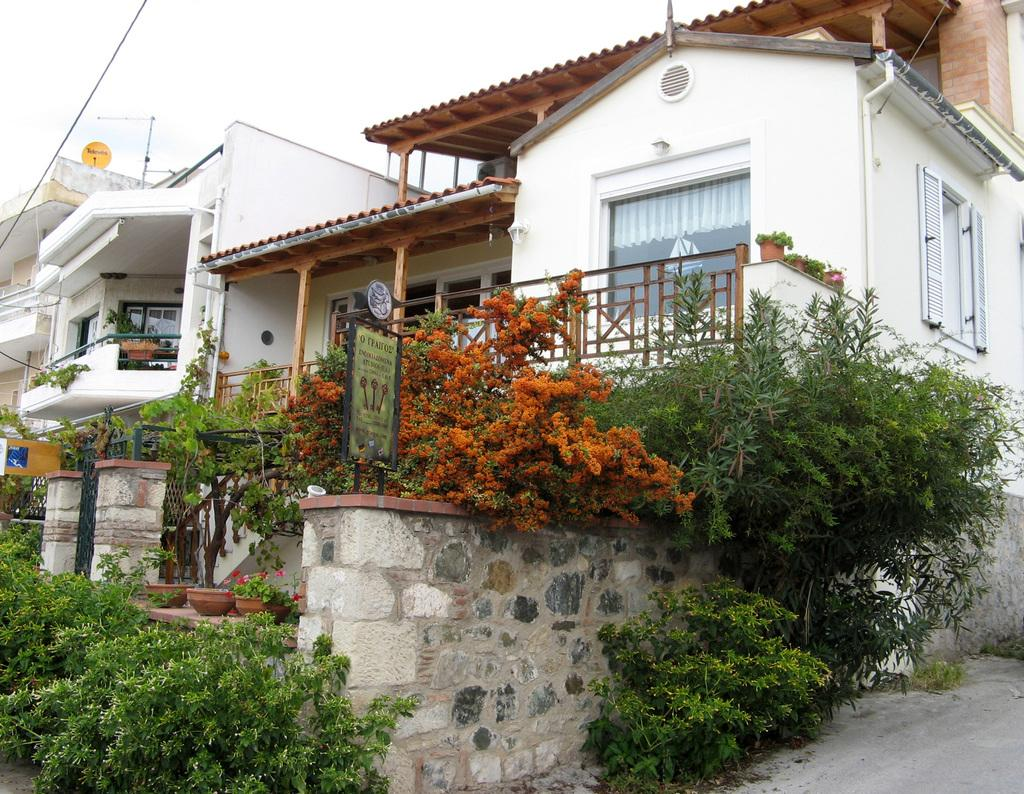What is located in the front of the image? There are plants in the front of the image. What can be seen on the board in the image? There is text on the board in the image. What type of structures are visible in the background of the image? There are houses in the background of the image. How would you describe the sky in the image? The sky is cloudy in the image. What type of club does the son use to play in the image? There is no son or club present in the image. What color is the powder that is sprinkled on the plants in the image? There is no powder present on the plants in the image. 